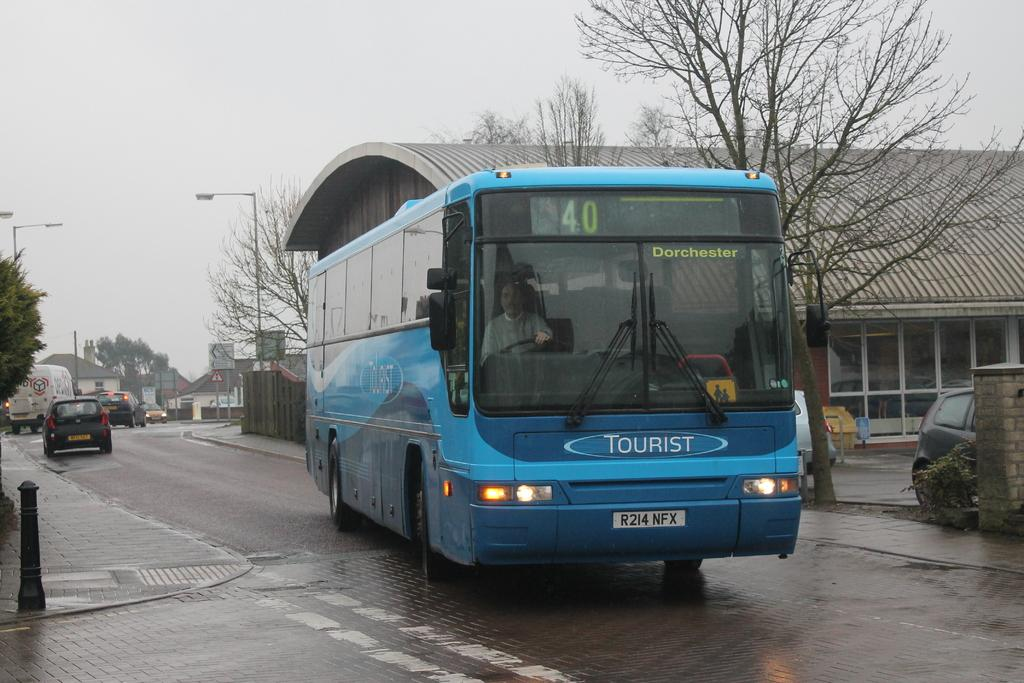Provide a one-sentence caption for the provided image. city bus number 40 is driving on the road. 